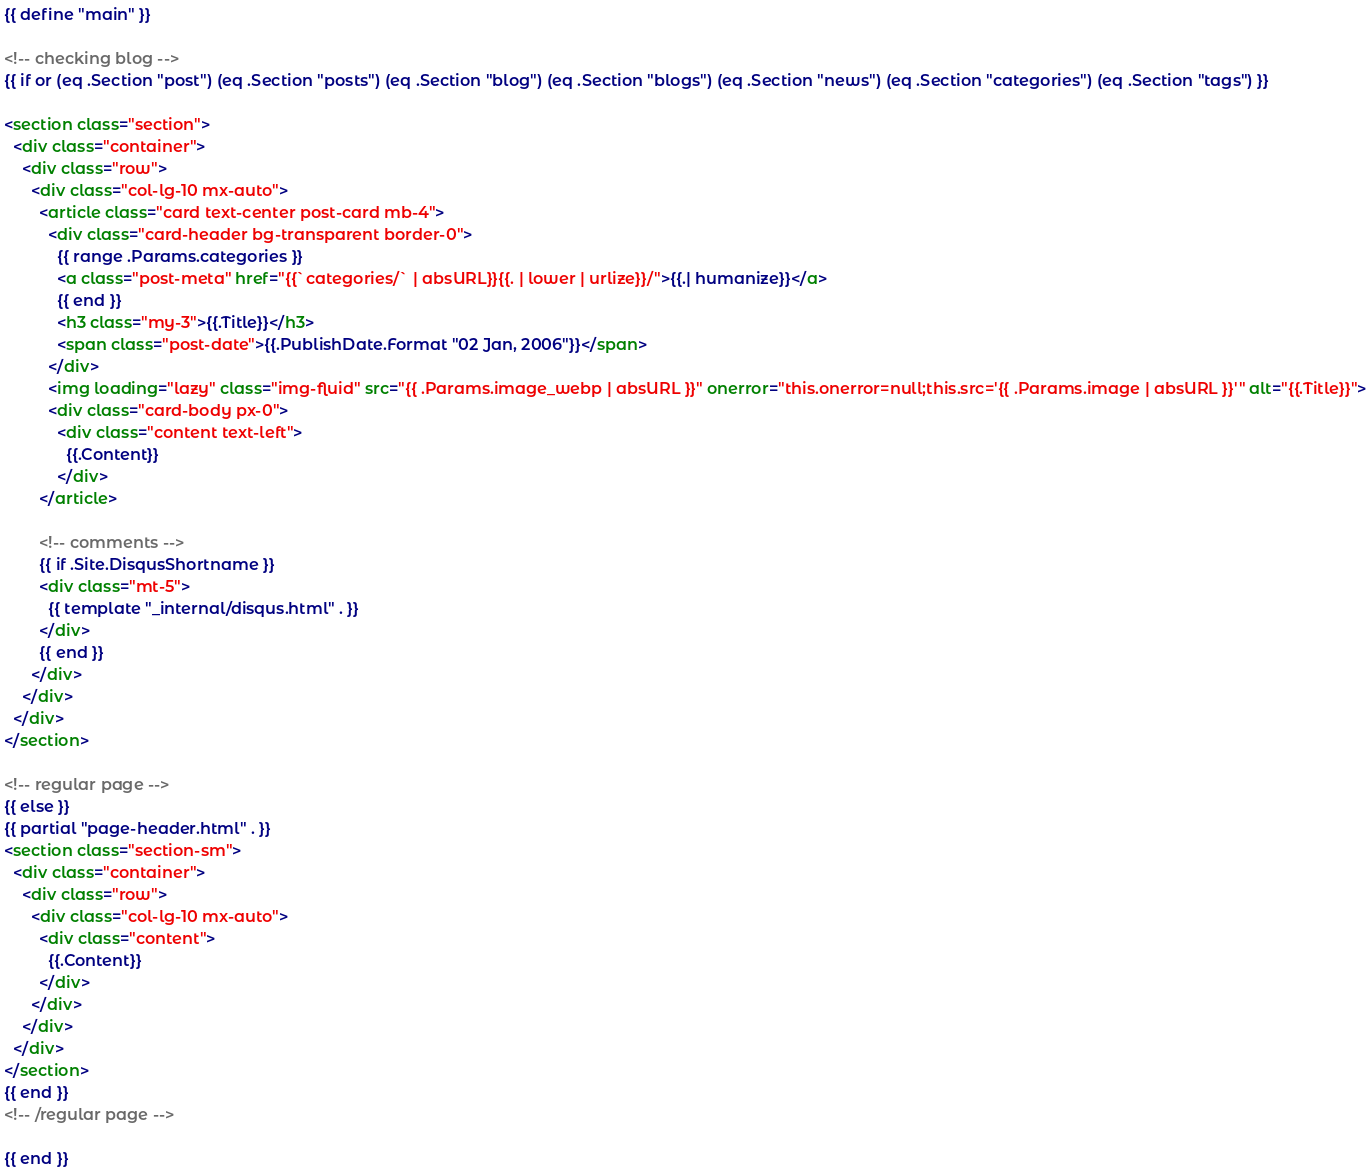<code> <loc_0><loc_0><loc_500><loc_500><_HTML_>{{ define "main" }}

<!-- checking blog -->
{{ if or (eq .Section "post") (eq .Section "posts") (eq .Section "blog") (eq .Section "blogs") (eq .Section "news") (eq .Section "categories") (eq .Section "tags") }}

<section class="section">
  <div class="container">
    <div class="row">
      <div class="col-lg-10 mx-auto">
        <article class="card text-center post-card mb-4">
          <div class="card-header bg-transparent border-0">
            {{ range .Params.categories }}
            <a class="post-meta" href="{{`categories/` | absURL}}{{. | lower | urlize}}/">{{.| humanize}}</a>
            {{ end }}
            <h3 class="my-3">{{.Title}}</h3>
            <span class="post-date">{{.PublishDate.Format "02 Jan, 2006"}}</span>
          </div>
          <img loading="lazy" class="img-fluid" src="{{ .Params.image_webp | absURL }}" onerror="this.onerror=null;this.src='{{ .Params.image | absURL }}'" alt="{{.Title}}">
          <div class="card-body px-0">
            <div class="content text-left">
              {{.Content}}
            </div>
        </article>

        <!-- comments -->
        {{ if .Site.DisqusShortname }}
        <div class="mt-5">
          {{ template "_internal/disqus.html" . }}
        </div>
        {{ end }}
      </div>
    </div>
  </div>
</section>

<!-- regular page -->
{{ else }}
{{ partial "page-header.html" . }}
<section class="section-sm">
  <div class="container">
    <div class="row">
      <div class="col-lg-10 mx-auto">
        <div class="content">
          {{.Content}}
        </div>
      </div>
    </div>
  </div>
</section>
{{ end }}
<!-- /regular page -->

{{ end }}</code> 